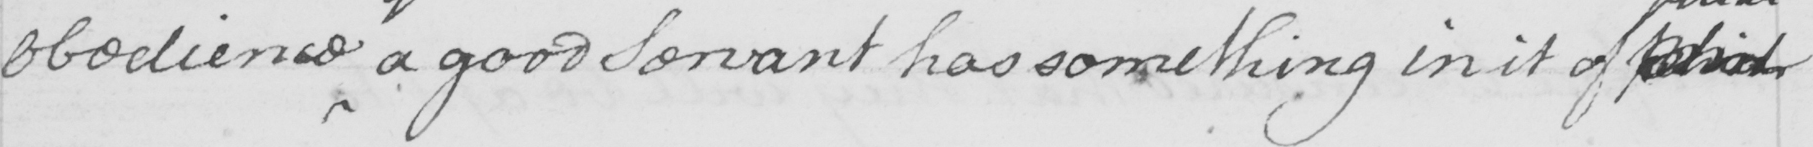Please transcribe the handwritten text in this image. obedience a good servant has something in it of persons 